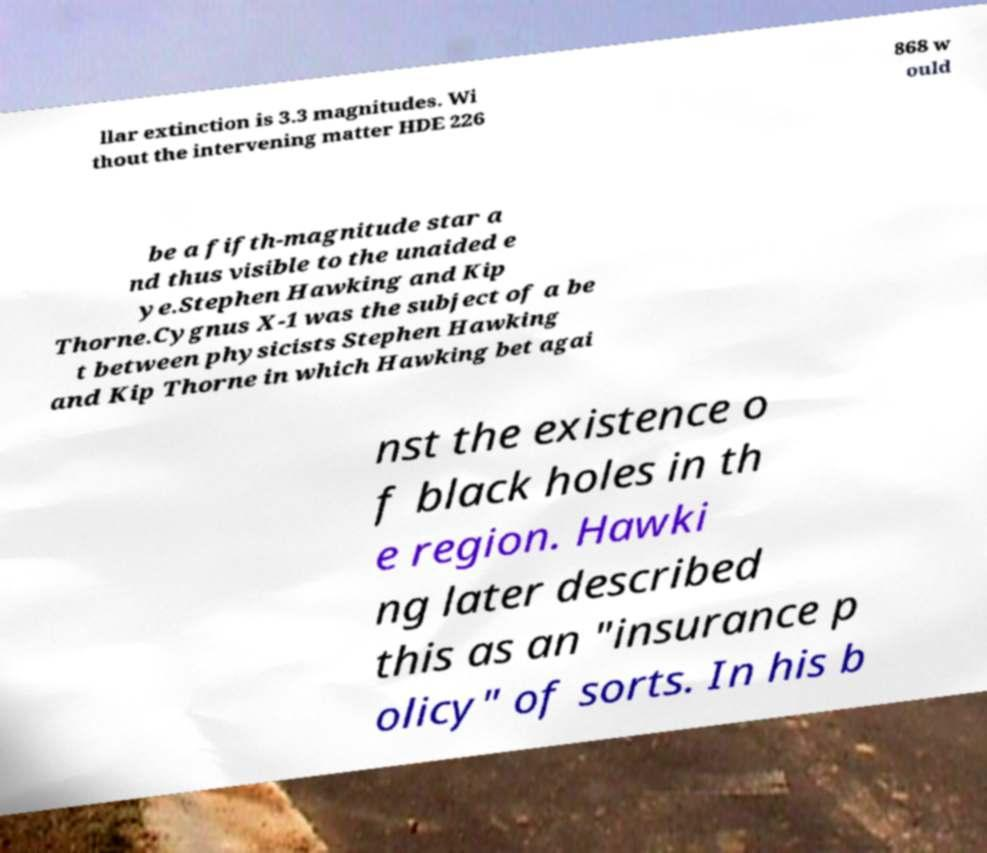Please identify and transcribe the text found in this image. llar extinction is 3.3 magnitudes. Wi thout the intervening matter HDE 226 868 w ould be a fifth-magnitude star a nd thus visible to the unaided e ye.Stephen Hawking and Kip Thorne.Cygnus X-1 was the subject of a be t between physicists Stephen Hawking and Kip Thorne in which Hawking bet agai nst the existence o f black holes in th e region. Hawki ng later described this as an "insurance p olicy" of sorts. In his b 